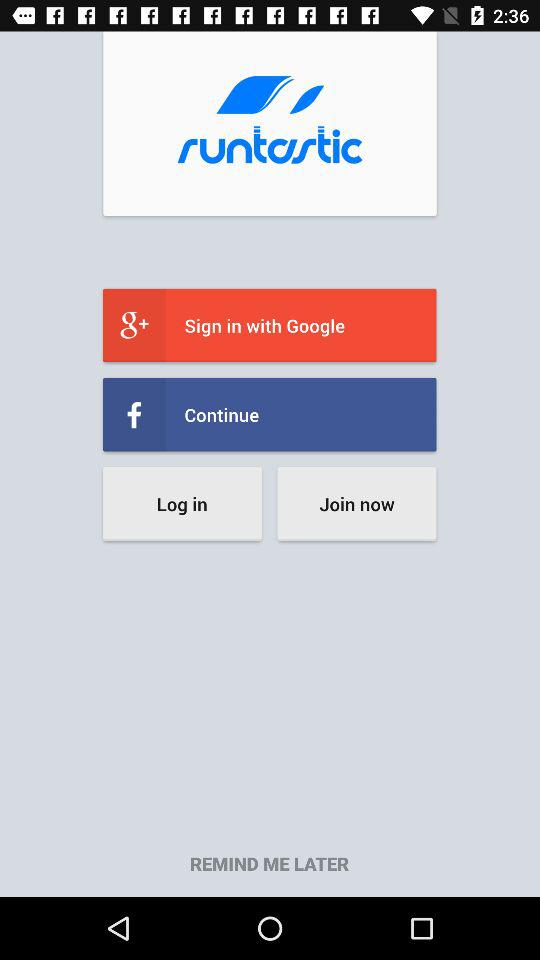What is the name of the application? The name of the application is "runtastic". 